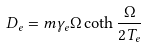Convert formula to latex. <formula><loc_0><loc_0><loc_500><loc_500>D _ { e } = m \gamma _ { e } \Omega \coth \frac { \Omega } { 2 T _ { e } }</formula> 